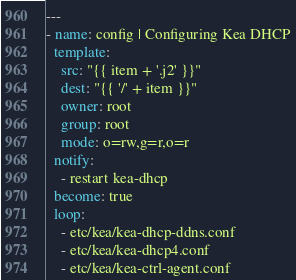<code> <loc_0><loc_0><loc_500><loc_500><_YAML_>---
- name: config | Configuring Kea DHCP
  template:
    src: "{{ item + '.j2' }}"
    dest: "{{ '/' + item }}"
    owner: root
    group: root
    mode: o=rw,g=r,o=r
  notify:
    - restart kea-dhcp
  become: true
  loop:
    - etc/kea/kea-dhcp-ddns.conf
    - etc/kea/kea-dhcp4.conf
    - etc/kea/kea-ctrl-agent.conf
</code> 